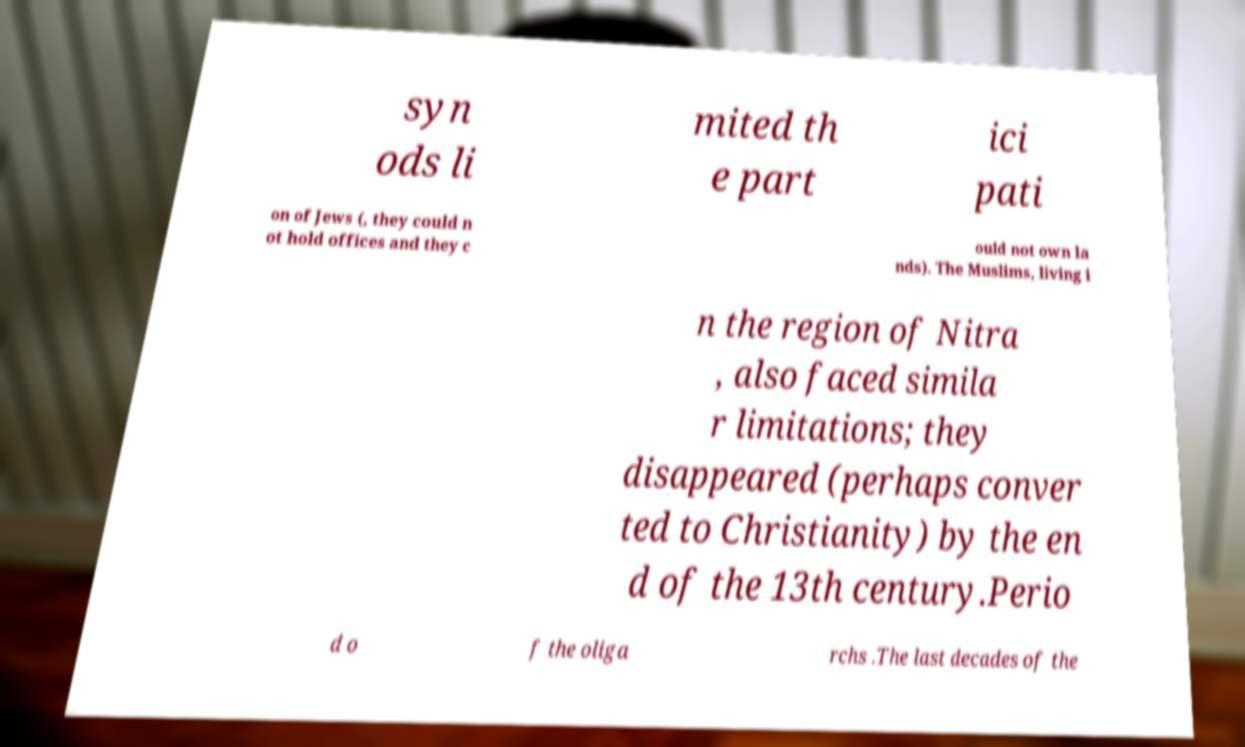I need the written content from this picture converted into text. Can you do that? syn ods li mited th e part ici pati on of Jews (, they could n ot hold offices and they c ould not own la nds). The Muslims, living i n the region of Nitra , also faced simila r limitations; they disappeared (perhaps conver ted to Christianity) by the en d of the 13th century.Perio d o f the oliga rchs .The last decades of the 